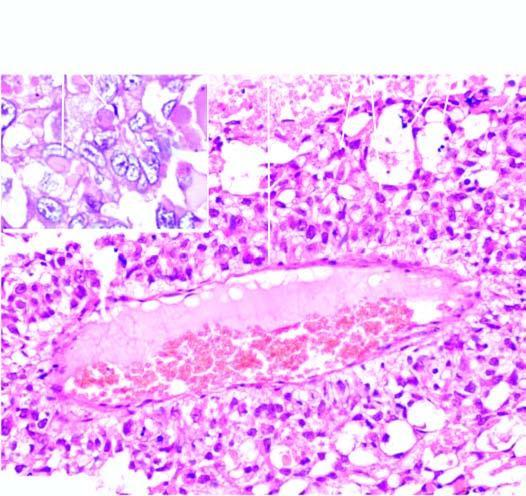re several characteristic schiller-duval bodies present?
Answer the question using a single word or phrase. Yes 